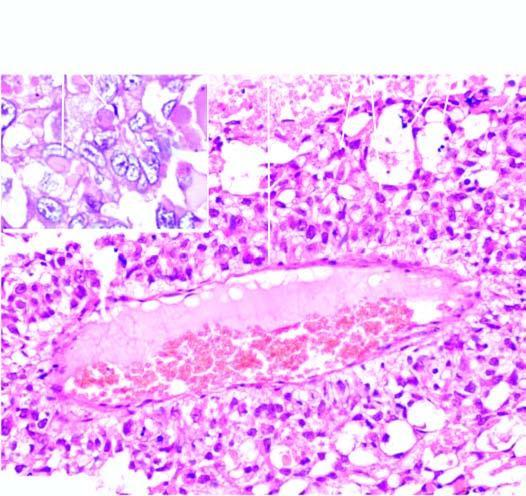re several characteristic schiller-duval bodies present?
Answer the question using a single word or phrase. Yes 